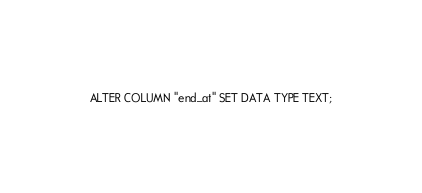Convert code to text. <code><loc_0><loc_0><loc_500><loc_500><_SQL_>ALTER COLUMN "end_at" SET DATA TYPE TEXT;
</code> 